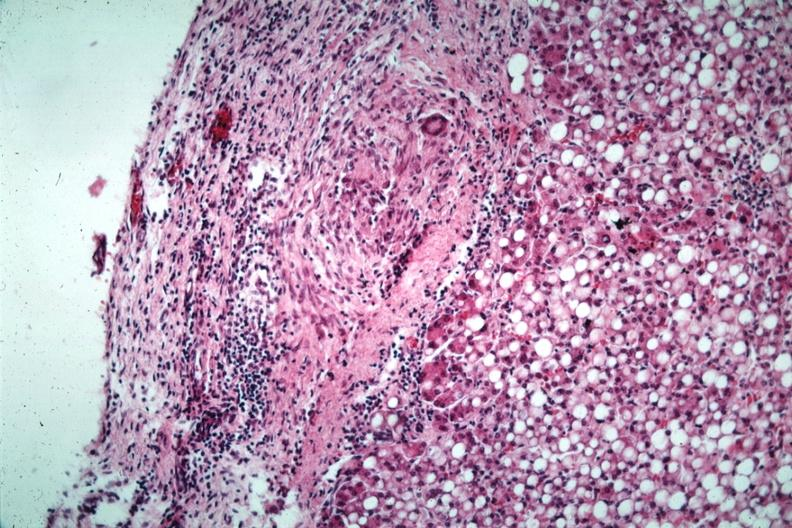what do liver with tuberculoid granuloma in glissons capsule?
Answer the question using a single word or phrase. Quite good has marked fatty change 